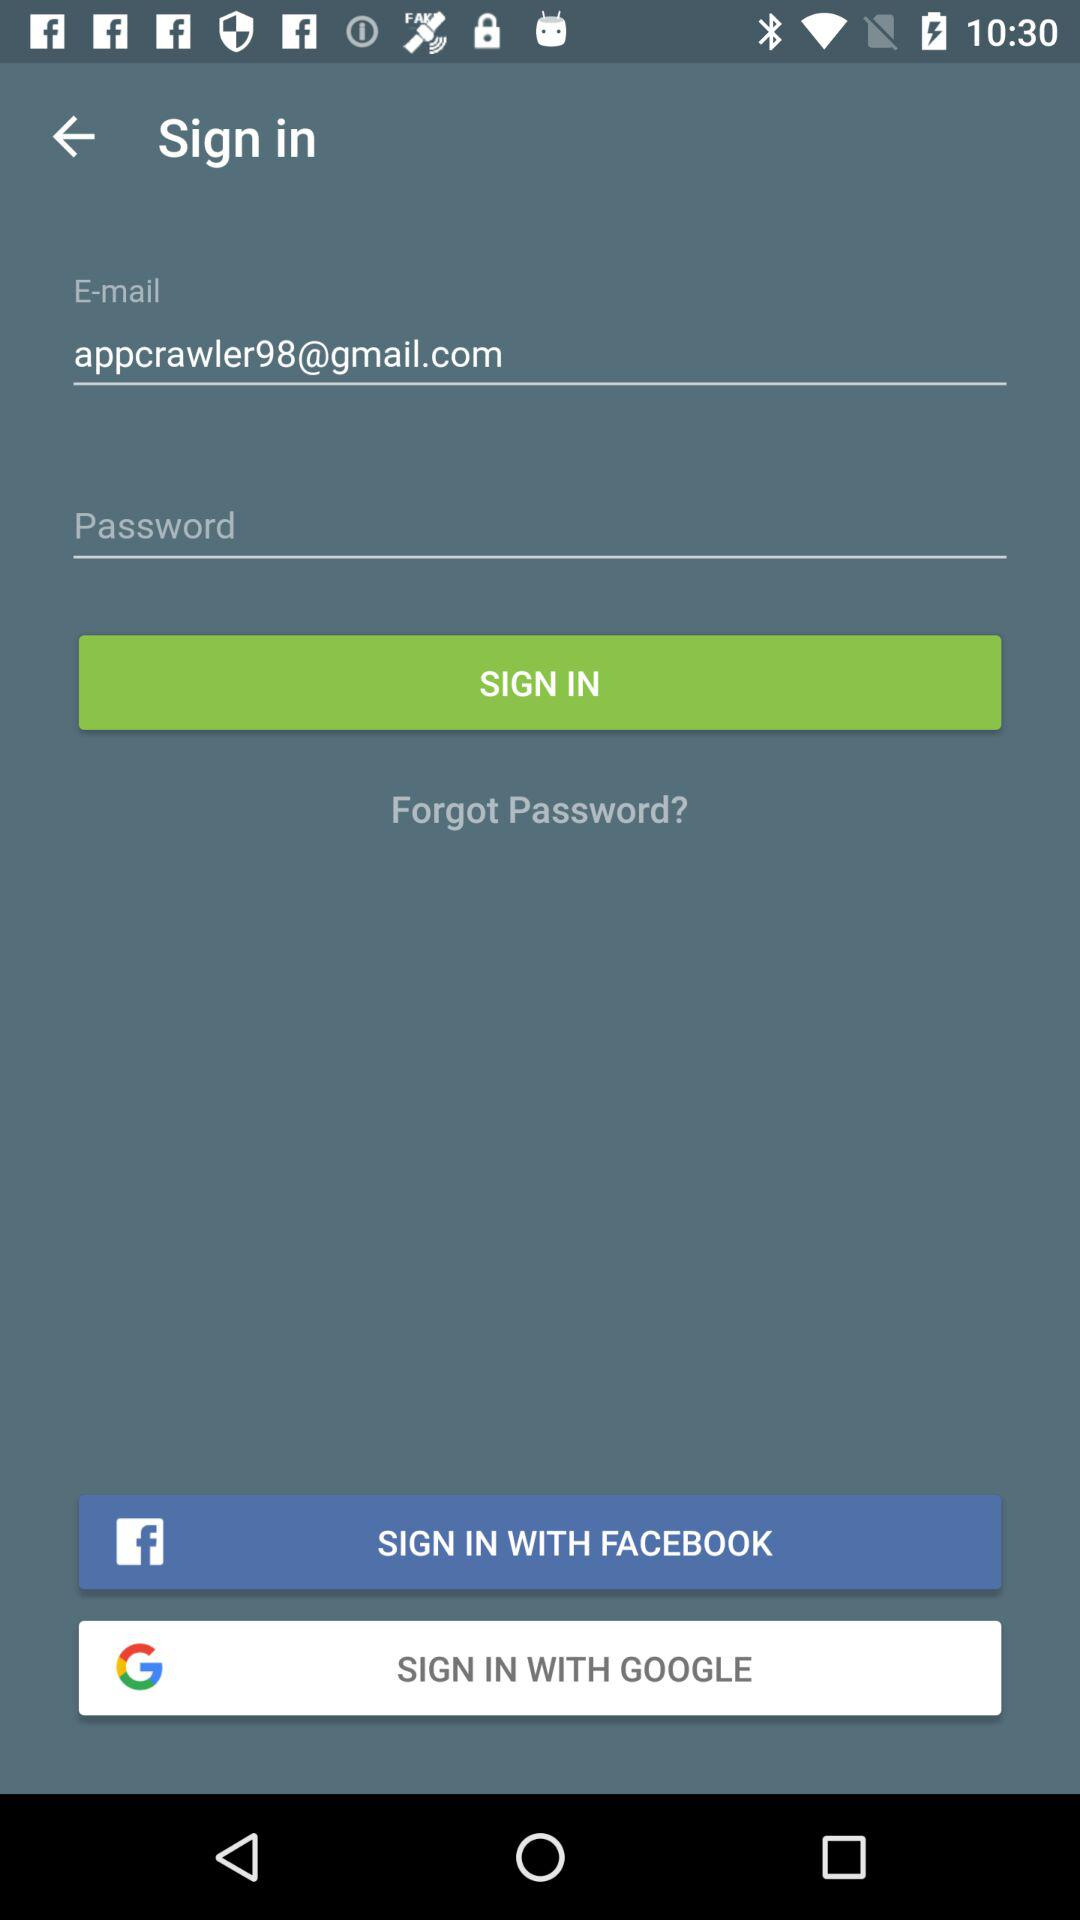How many characters are required to create a password?
When the provided information is insufficient, respond with <no answer>. <no answer> 